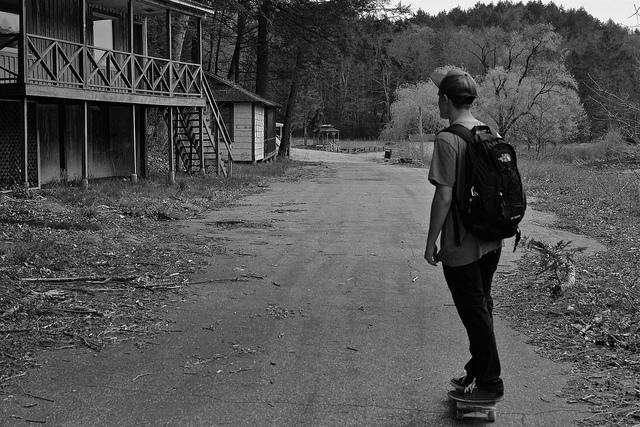What color is the bag?
Answer briefly. Black. Is this an underground water tunnel?
Concise answer only. No. How many people are in this picture?
Answer briefly. 1. Is this a young man?
Short answer required. Yes. Is this man dressed professionally?
Be succinct. No. Is the man an animal lover?
Keep it brief. No. Is everyone wearing tennis shoes?
Quick response, please. Yes. Which people wear backpacks?
Be succinct. Man. Why are the mountains copper-colored?
Quick response, please. Fall leaves. What is the boy doing?
Concise answer only. Skateboarding. How did the bags get there?
Short answer required. On back. How many people are there?
Answer briefly. 1. Is the boy a hiking?
Short answer required. No. What is the road made of?
Answer briefly. Asphalt. Is he dressed casually?
Give a very brief answer. Yes. Is this a good road to drive down?
Short answer required. No. Is this a paved road?
Be succinct. No. Is there a stop sign?
Answer briefly. No. What color are the blooms?
Write a very short answer. Gray. What is in the picture?
Concise answer only. Man. Was this picture taken during the winter?
Be succinct. No. Can you see water?
Quick response, please. No. Is this skateboarder going to fall?
Concise answer only. No. Is the image in black and white?
Concise answer only. Yes. Are there any vehicles in the picture?
Answer briefly. No. What does the man have on his bag?
Write a very short answer. Zippers. How many fence pickets are visible in the picture?
Write a very short answer. 0. Is the man standing on both feet?
Give a very brief answer. Yes. How many people wear sneakers?
Be succinct. 1. Is the man wearing a short-sleeved shirt?
Give a very brief answer. Yes. How many buildings are seen in the photo?
Write a very short answer. 2. Is the boy standing?
Give a very brief answer. Yes. Is this individual approaching an incline or decline?
Answer briefly. Incline. What are they doing?
Answer briefly. Skateboarding. What is on the ground?
Short answer required. Dirt. Are they walking on brick?
Quick response, please. No. Does the road need some maintenance?
Answer briefly. Yes. What is the man wearing?
Be succinct. Backpack. How many people are riding skateboards on this street?
Answer briefly. 1. What is the man doing?
Be succinct. Skateboarding. Is this person wearing a hat?
Give a very brief answer. Yes. Do the shoes have buckles?
Keep it brief. No. Is the building new?
Answer briefly. No. What color is the car behind the woman?
Be succinct. No car. Does the boy have his legs spread?
Keep it brief. No. Is he wearing a shirt?
Answer briefly. Yes. Do the suitcases have wheels?
Be succinct. No. 